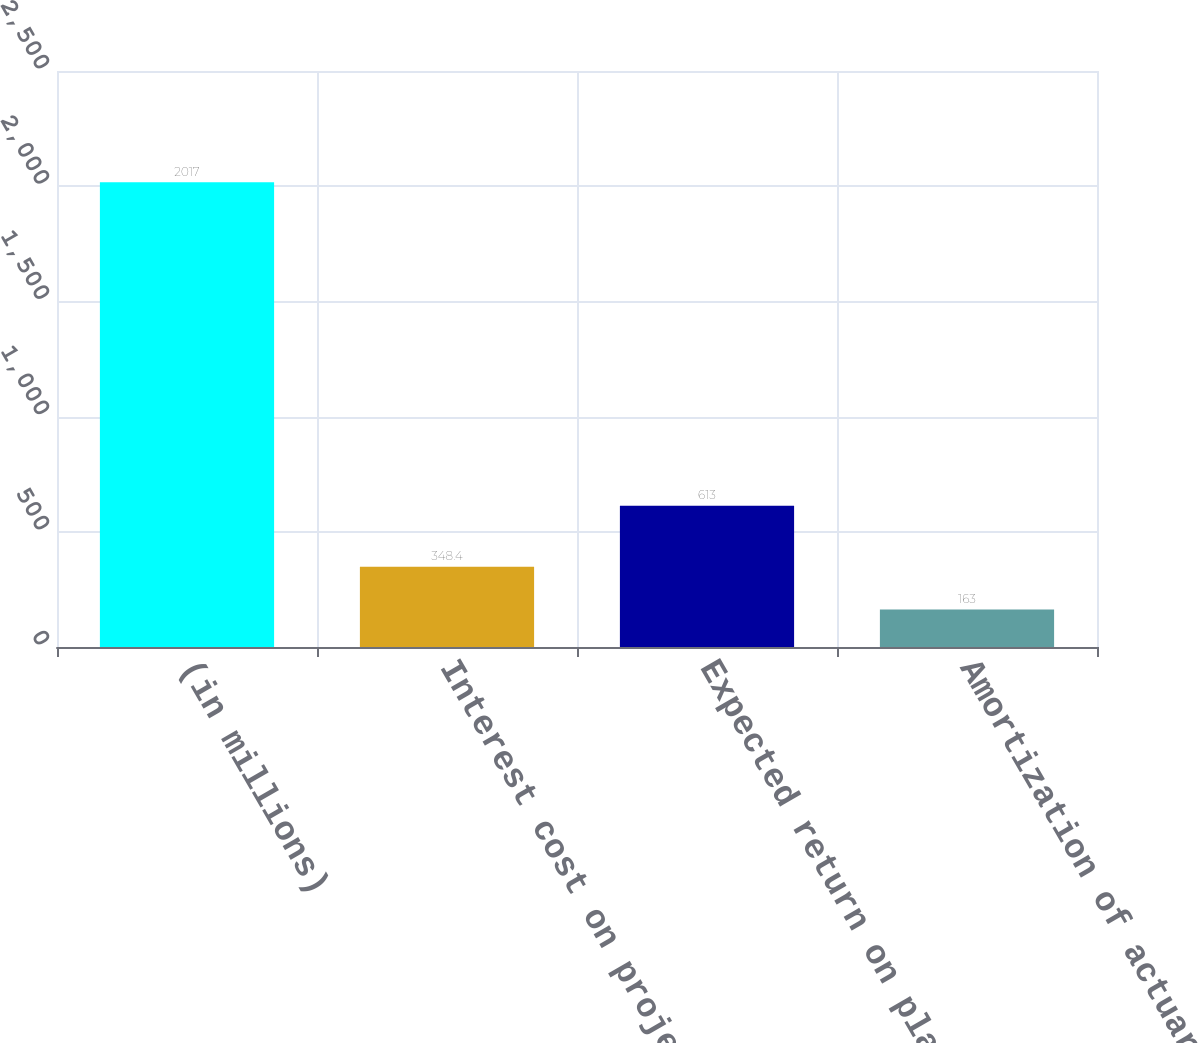<chart> <loc_0><loc_0><loc_500><loc_500><bar_chart><fcel>(in millions)<fcel>Interest cost on projected<fcel>Expected return on plans'<fcel>Amortization of actuarial<nl><fcel>2017<fcel>348.4<fcel>613<fcel>163<nl></chart> 